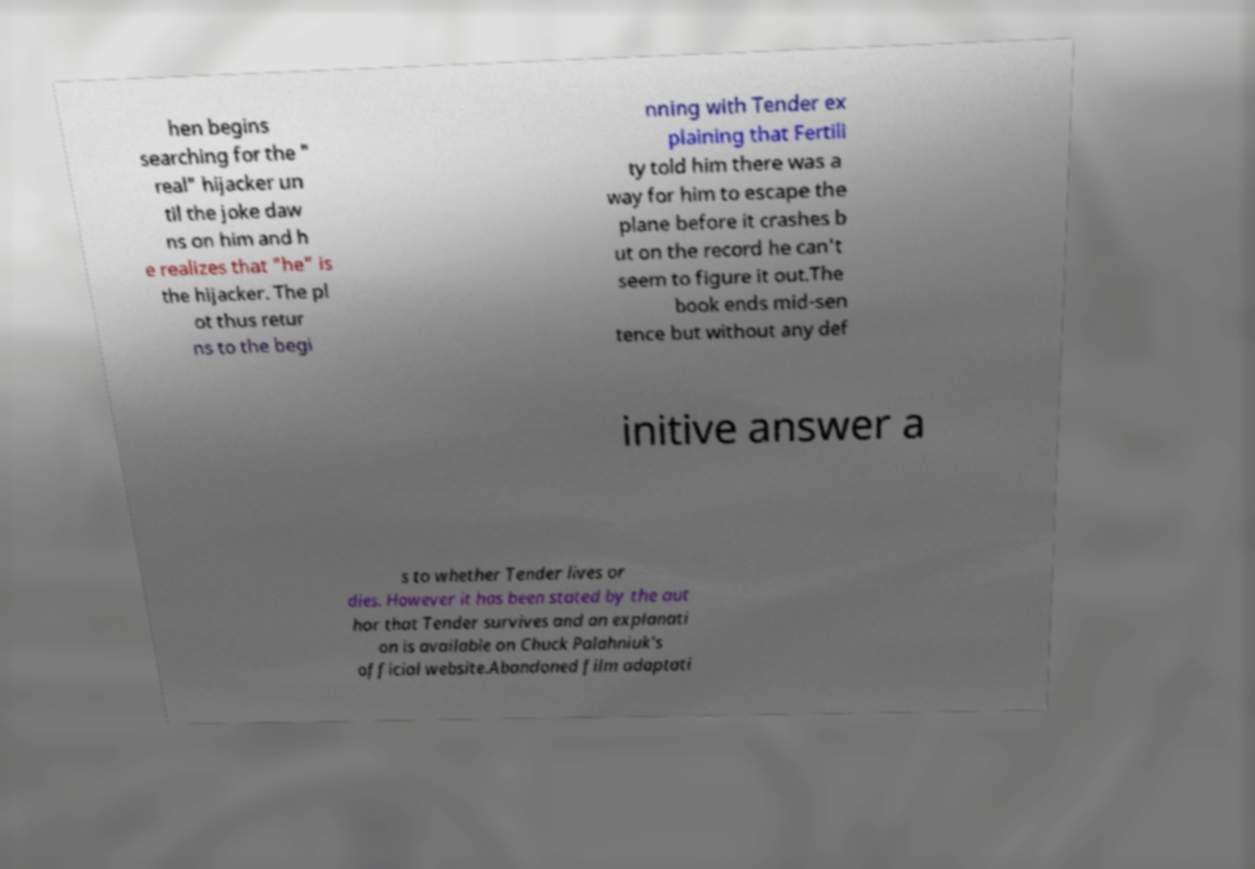Please identify and transcribe the text found in this image. hen begins searching for the " real" hijacker un til the joke daw ns on him and h e realizes that "he" is the hijacker. The pl ot thus retur ns to the begi nning with Tender ex plaining that Fertili ty told him there was a way for him to escape the plane before it crashes b ut on the record he can't seem to figure it out.The book ends mid-sen tence but without any def initive answer a s to whether Tender lives or dies. However it has been stated by the aut hor that Tender survives and an explanati on is available on Chuck Palahniuk's official website.Abandoned film adaptati 